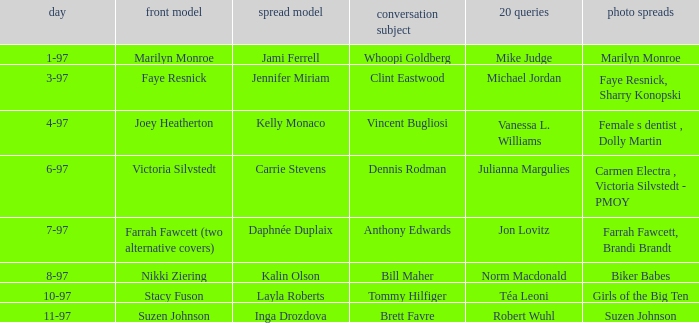What is the name of the cover model on 3-97? Faye Resnick. Would you be able to parse every entry in this table? {'header': ['day', 'front model', 'spread model', 'conversation subject', '20 queries', 'photo spreads'], 'rows': [['1-97', 'Marilyn Monroe', 'Jami Ferrell', 'Whoopi Goldberg', 'Mike Judge', 'Marilyn Monroe'], ['3-97', 'Faye Resnick', 'Jennifer Miriam', 'Clint Eastwood', 'Michael Jordan', 'Faye Resnick, Sharry Konopski'], ['4-97', 'Joey Heatherton', 'Kelly Monaco', 'Vincent Bugliosi', 'Vanessa L. Williams', 'Female s dentist , Dolly Martin'], ['6-97', 'Victoria Silvstedt', 'Carrie Stevens', 'Dennis Rodman', 'Julianna Margulies', 'Carmen Electra , Victoria Silvstedt - PMOY'], ['7-97', 'Farrah Fawcett (two alternative covers)', 'Daphnée Duplaix', 'Anthony Edwards', 'Jon Lovitz', 'Farrah Fawcett, Brandi Brandt'], ['8-97', 'Nikki Ziering', 'Kalin Olson', 'Bill Maher', 'Norm Macdonald', 'Biker Babes'], ['10-97', 'Stacy Fuson', 'Layla Roberts', 'Tommy Hilfiger', 'Téa Leoni', 'Girls of the Big Ten'], ['11-97', 'Suzen Johnson', 'Inga Drozdova', 'Brett Favre', 'Robert Wuhl', 'Suzen Johnson']]} 